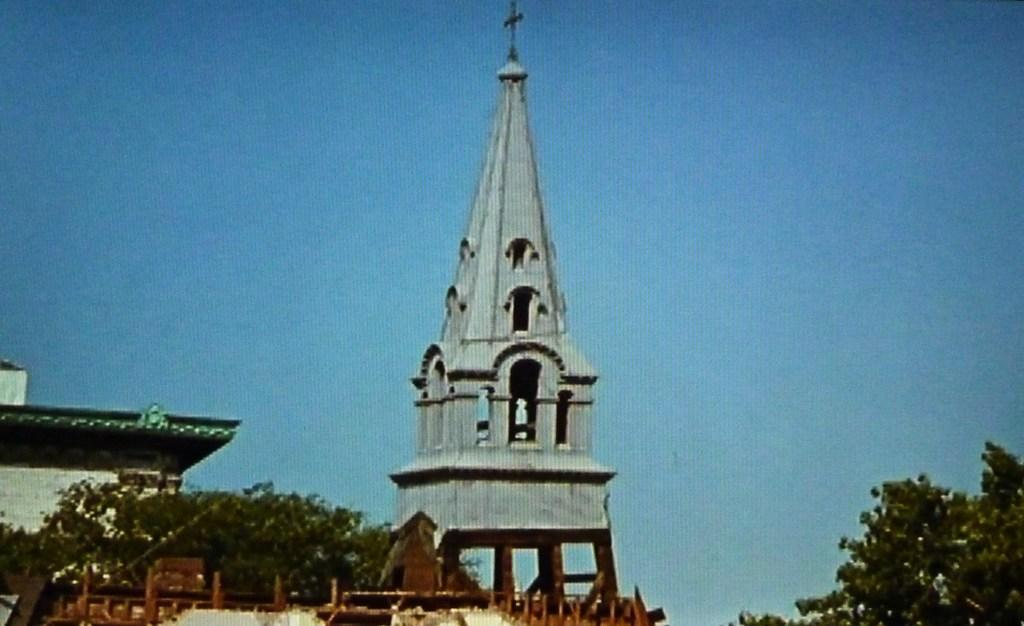What type of building is in the image? There is a church building in the image. Are there any other structures or objects near the church building? Yes, there are trees around the church building. What type of food is being served in the church building in the image? There is no indication of food being served in the image; it only shows a church building and trees around it. 